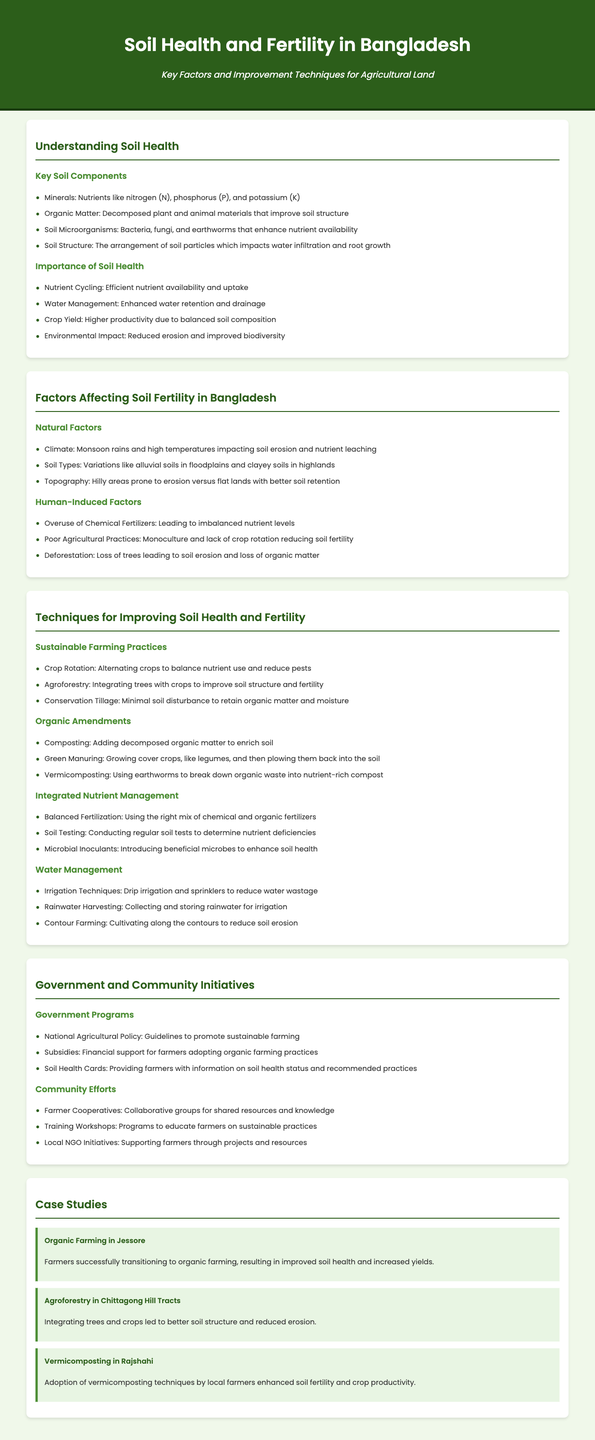what are the key soil components? The key soil components mentioned in the document are minerals, organic matter, soil microorganisms, and soil structure.
Answer: minerals, organic matter, soil microorganisms, soil structure what is one natural factor affecting soil fertility in Bangladesh? The document lists climate, soil types, and topography as natural factors affecting soil fertility. One example is climate.
Answer: climate name a technique for improving soil health and fertility. Several techniques are described, including crop rotation, agroforestry, and conservation tillage. An example is crop rotation.
Answer: crop rotation what is a benefit of organic amendments? The document states that organic amendments enrich soil, improve fertility, and enhance productivity. The specific benefit is enriching soil.
Answer: enriching soil which government program promotes sustainable farming? The National Agricultural Policy is highlighted as a government program promoting sustainable farming.
Answer: National Agricultural Policy how does agroforestry benefit soil? The document explains that agroforestry leads to improved soil structure and reduced erosion.
Answer: improved soil structure what is a common consequence of overuse of chemical fertilizers? The document states that overuse of chemical fertilizers leads to imbalanced nutrient levels.
Answer: imbalanced nutrient levels who are involved in community efforts to improve soil health? The document mentions farmer cooperatives, training workshops, and local NGO initiatives as community efforts.
Answer: farmer cooperatives what was the outcome of the organic farming case study in Jessore? The case study indicates that farmers transitioning to organic farming resulted in improved soil health and increased yields.
Answer: improved soil health and increased yields 